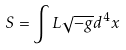Convert formula to latex. <formula><loc_0><loc_0><loc_500><loc_500>S = \int L \sqrt { - g } d ^ { 4 } x</formula> 